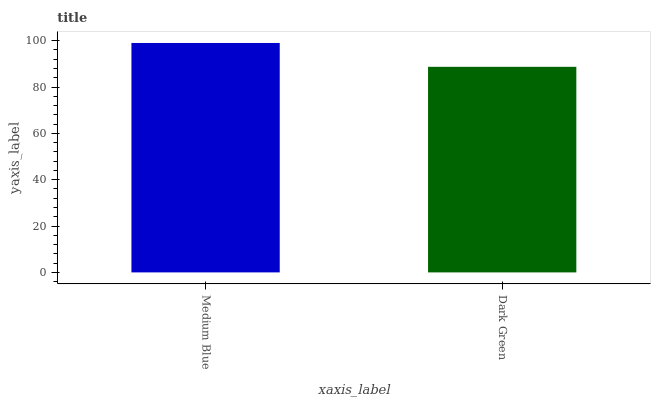Is Dark Green the minimum?
Answer yes or no. Yes. Is Medium Blue the maximum?
Answer yes or no. Yes. Is Dark Green the maximum?
Answer yes or no. No. Is Medium Blue greater than Dark Green?
Answer yes or no. Yes. Is Dark Green less than Medium Blue?
Answer yes or no. Yes. Is Dark Green greater than Medium Blue?
Answer yes or no. No. Is Medium Blue less than Dark Green?
Answer yes or no. No. Is Medium Blue the high median?
Answer yes or no. Yes. Is Dark Green the low median?
Answer yes or no. Yes. Is Dark Green the high median?
Answer yes or no. No. Is Medium Blue the low median?
Answer yes or no. No. 